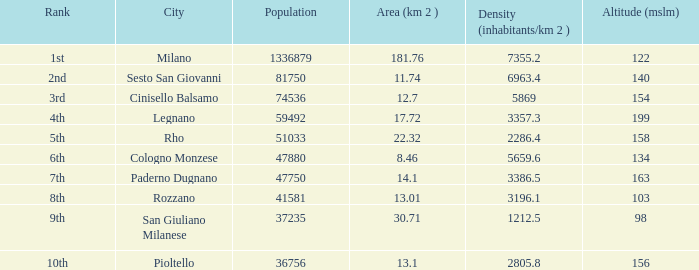Which Population is the highest one that has a Density (inhabitants/km 2) larger than 2805.8, and a Rank of 1st, and an Altitude (mslm) smaller than 122? None. 